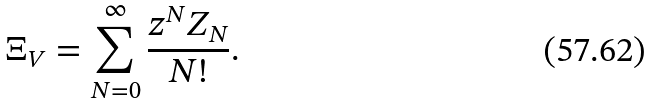<formula> <loc_0><loc_0><loc_500><loc_500>\Xi _ { V } = \sum _ { N = 0 } ^ { \infty } \frac { z ^ { N } Z _ { N } } { N ! } .</formula> 